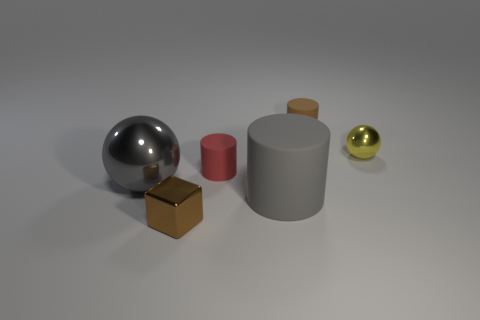Add 4 small brown matte things. How many objects exist? 10 Subtract all spheres. How many objects are left? 4 Add 2 brown metal blocks. How many brown metal blocks are left? 3 Add 2 cyan metal things. How many cyan metal things exist? 2 Subtract 0 blue spheres. How many objects are left? 6 Subtract all tiny blue metal cylinders. Subtract all large gray things. How many objects are left? 4 